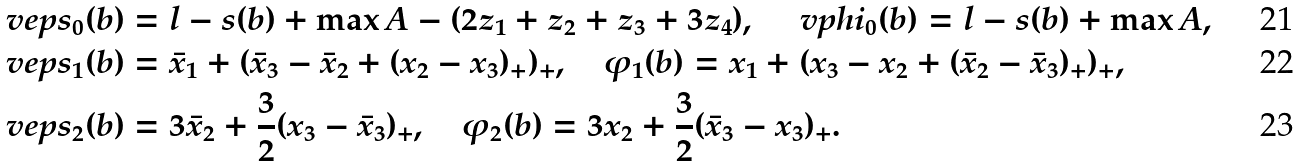<formula> <loc_0><loc_0><loc_500><loc_500>& \ v e p s _ { 0 } ( b ) = l - s ( b ) + \max A - ( 2 z _ { 1 } + z _ { 2 } + z _ { 3 } + 3 z _ { 4 } ) , \quad \ v p h i _ { 0 } ( b ) = l - s ( b ) + \max A , \\ & \ v e p s _ { 1 } ( b ) = { \bar { x } } _ { 1 } + ( { \bar { x } } _ { 3 } - { \bar { x } } _ { 2 } + ( x _ { 2 } - x _ { 3 } ) _ { + } ) _ { + } , \quad \varphi _ { 1 } ( b ) = x _ { 1 } + ( x _ { 3 } - x _ { 2 } + ( { \bar { x } } _ { 2 } - { \bar { x } } _ { 3 } ) _ { + } ) _ { + } , \\ & \ v e p s _ { 2 } ( b ) = 3 { \bar { x } } _ { 2 } + \frac { 3 } { 2 } ( x _ { 3 } - { \bar { x } } _ { 3 } ) _ { + } , \quad \varphi _ { 2 } ( b ) = 3 x _ { 2 } + \frac { 3 } { 2 } ( { \bar { x } } _ { 3 } - x _ { 3 } ) _ { + } .</formula> 